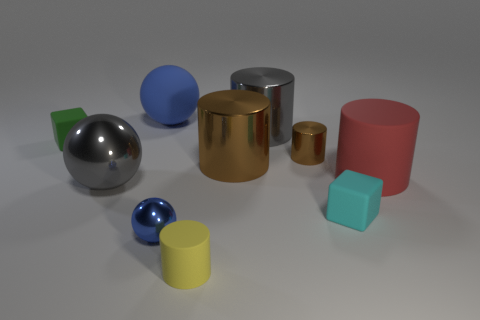What is the shape of the blue rubber object that is the same size as the red cylinder?
Provide a short and direct response. Sphere. Is there a metallic thing of the same color as the big matte ball?
Keep it short and to the point. Yes. Are there the same number of yellow cylinders that are to the left of the gray ball and objects in front of the blue matte thing?
Your answer should be compact. No. Does the big red matte object have the same shape as the small metallic object that is behind the big red thing?
Your response must be concise. Yes. What number of other things are the same material as the small brown object?
Ensure brevity in your answer.  4. Are there any red rubber cylinders on the left side of the tiny blue sphere?
Provide a succinct answer. No. There is a cyan thing; does it have the same size as the blue ball in front of the tiny green matte object?
Give a very brief answer. Yes. The matte block that is in front of the gray metallic object in front of the green thing is what color?
Make the answer very short. Cyan. Is the size of the red rubber cylinder the same as the cyan matte object?
Offer a terse response. No. What is the color of the large thing that is behind the tiny green matte object and to the right of the small yellow cylinder?
Make the answer very short. Gray. 